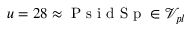<formula> <loc_0><loc_0><loc_500><loc_500>u = 2 8 \approx P s i d S p \in \mathcal { V } _ { p l }</formula> 